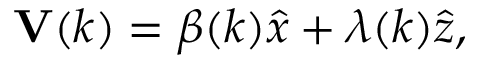Convert formula to latex. <formula><loc_0><loc_0><loc_500><loc_500>{ V } ( k ) = \beta ( k ) \hat { x } + \lambda ( k ) \hat { z } ,</formula> 